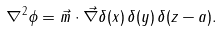<formula> <loc_0><loc_0><loc_500><loc_500>\nabla ^ { 2 } \phi = \vec { m } \cdot \vec { \nabla } \delta ( x ) \, \delta ( y ) \, \delta ( z - a ) .</formula> 